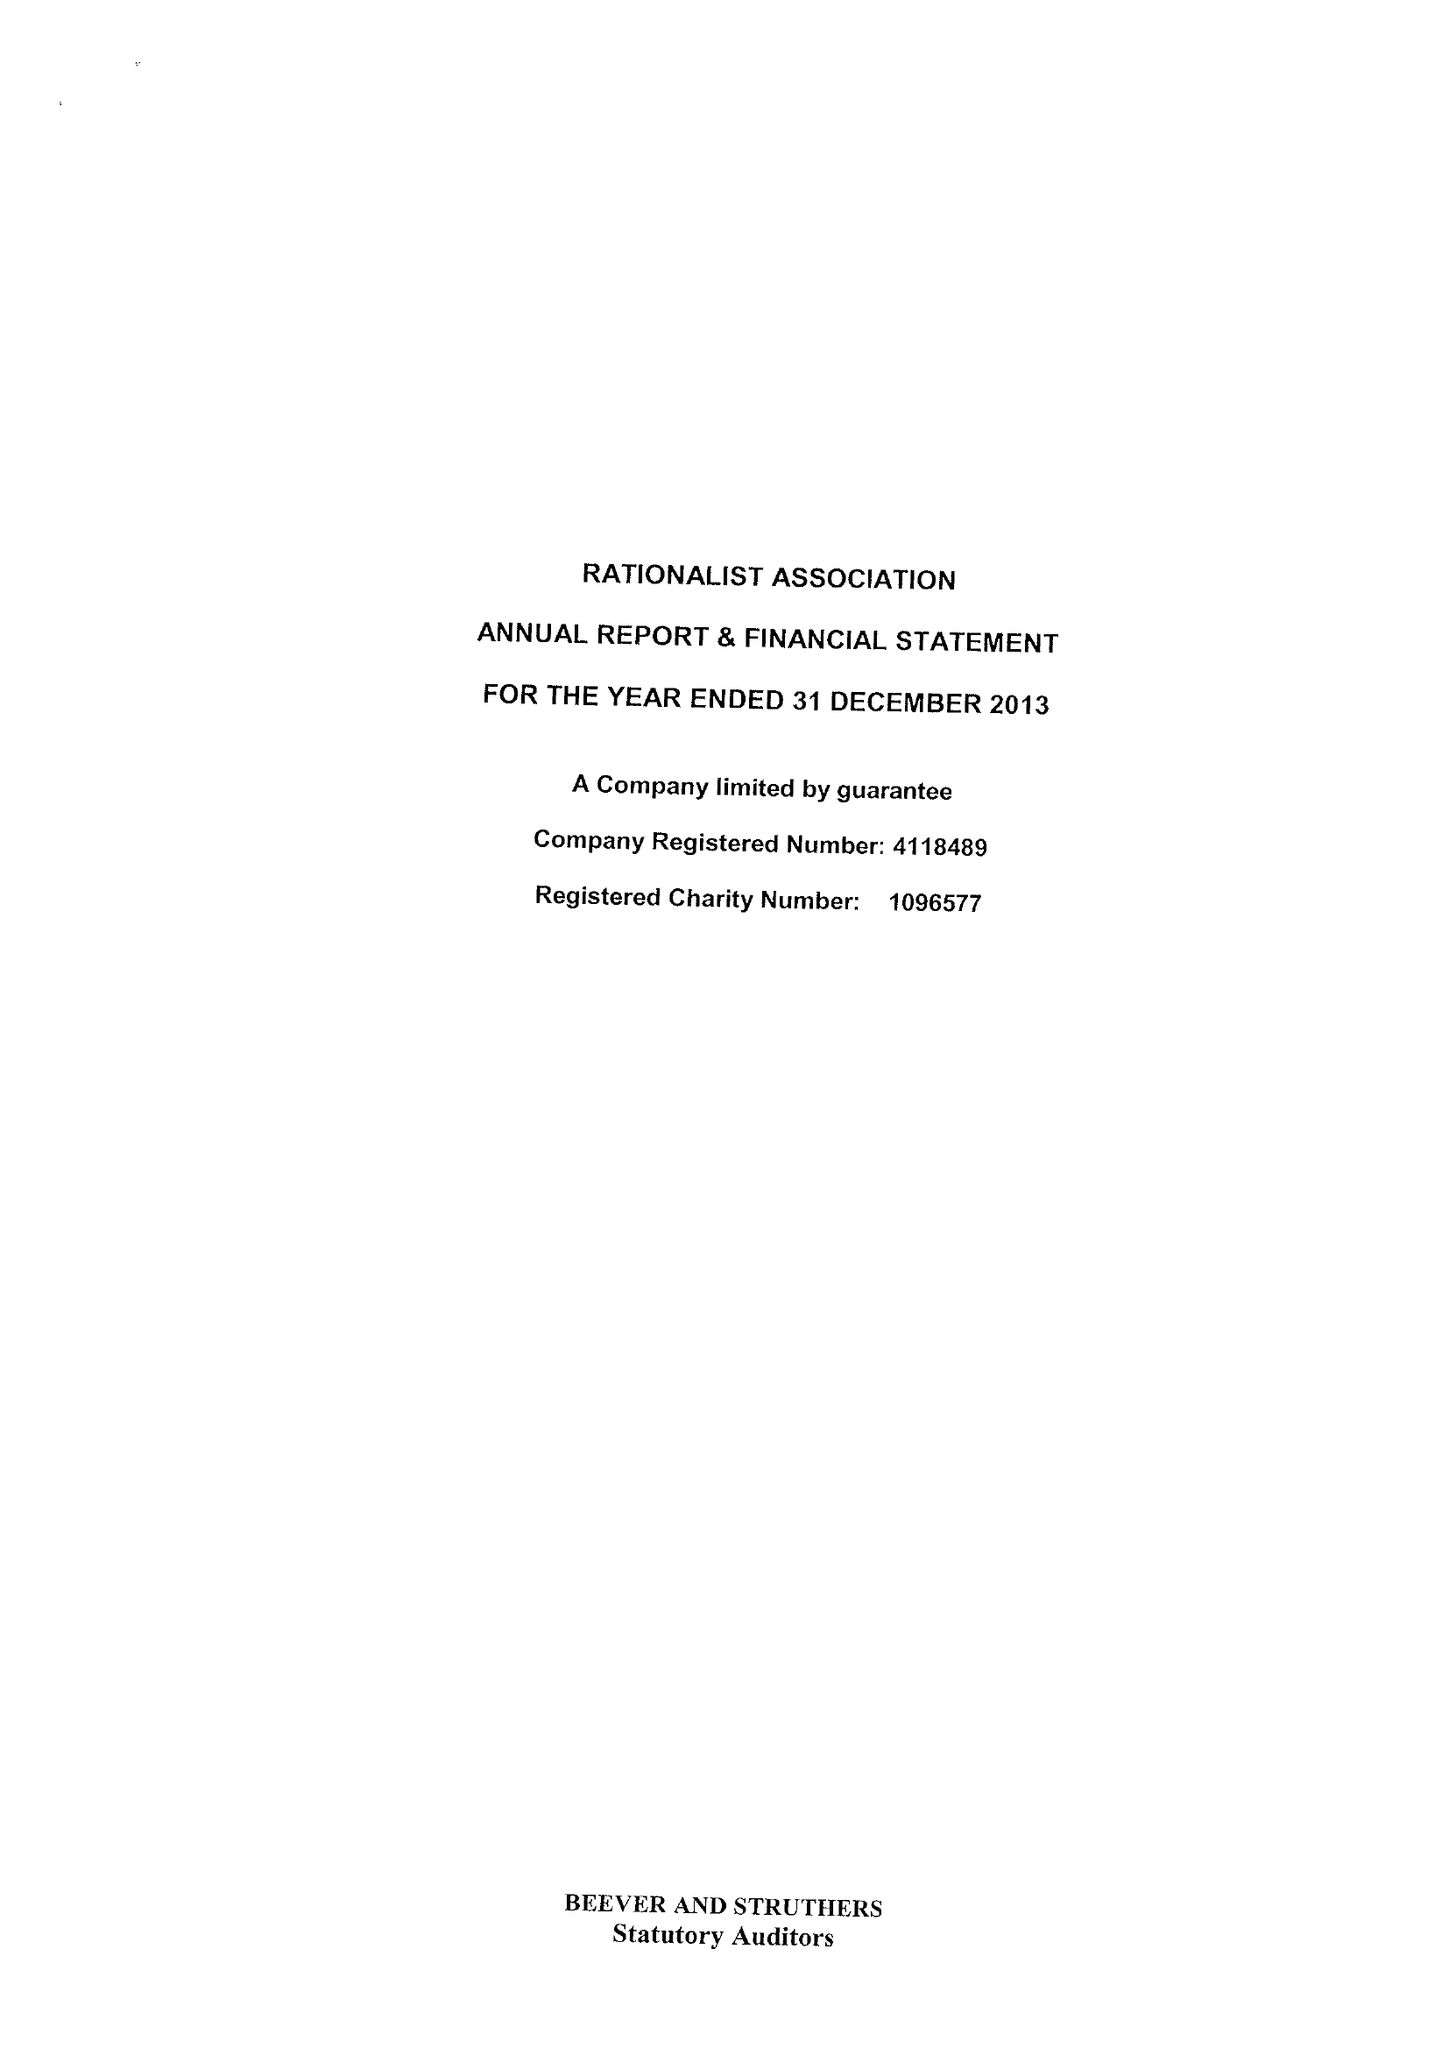What is the value for the spending_annually_in_british_pounds?
Answer the question using a single word or phrase. 291925.00 